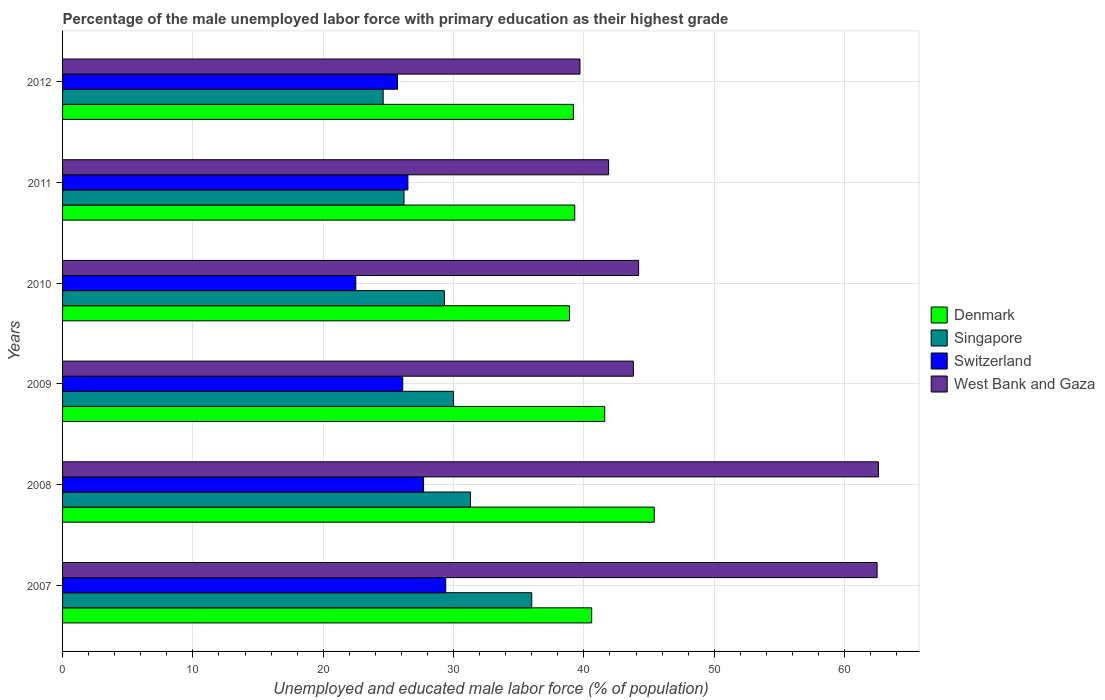How many groups of bars are there?
Your answer should be very brief. 6. How many bars are there on the 2nd tick from the bottom?
Give a very brief answer. 4. What is the label of the 4th group of bars from the top?
Provide a short and direct response. 2009. What is the percentage of the unemployed male labor force with primary education in Switzerland in 2008?
Offer a terse response. 27.7. Across all years, what is the maximum percentage of the unemployed male labor force with primary education in Denmark?
Offer a very short reply. 45.4. In which year was the percentage of the unemployed male labor force with primary education in Singapore minimum?
Give a very brief answer. 2012. What is the total percentage of the unemployed male labor force with primary education in Singapore in the graph?
Your response must be concise. 177.4. What is the difference between the percentage of the unemployed male labor force with primary education in Switzerland in 2008 and that in 2012?
Provide a succinct answer. 2. What is the difference between the percentage of the unemployed male labor force with primary education in Denmark in 2010 and the percentage of the unemployed male labor force with primary education in West Bank and Gaza in 2011?
Your response must be concise. -3. What is the average percentage of the unemployed male labor force with primary education in Switzerland per year?
Your answer should be compact. 26.32. In the year 2012, what is the difference between the percentage of the unemployed male labor force with primary education in West Bank and Gaza and percentage of the unemployed male labor force with primary education in Switzerland?
Your answer should be very brief. 14. What is the ratio of the percentage of the unemployed male labor force with primary education in West Bank and Gaza in 2008 to that in 2009?
Your answer should be compact. 1.43. Is the percentage of the unemployed male labor force with primary education in Denmark in 2008 less than that in 2012?
Keep it short and to the point. No. Is the difference between the percentage of the unemployed male labor force with primary education in West Bank and Gaza in 2007 and 2010 greater than the difference between the percentage of the unemployed male labor force with primary education in Switzerland in 2007 and 2010?
Give a very brief answer. Yes. What is the difference between the highest and the second highest percentage of the unemployed male labor force with primary education in Denmark?
Your answer should be very brief. 3.8. What is the difference between the highest and the lowest percentage of the unemployed male labor force with primary education in Singapore?
Provide a succinct answer. 11.4. Is it the case that in every year, the sum of the percentage of the unemployed male labor force with primary education in Denmark and percentage of the unemployed male labor force with primary education in Singapore is greater than the sum of percentage of the unemployed male labor force with primary education in Switzerland and percentage of the unemployed male labor force with primary education in West Bank and Gaza?
Give a very brief answer. Yes. What does the 3rd bar from the top in 2011 represents?
Your response must be concise. Singapore. Is it the case that in every year, the sum of the percentage of the unemployed male labor force with primary education in Singapore and percentage of the unemployed male labor force with primary education in West Bank and Gaza is greater than the percentage of the unemployed male labor force with primary education in Switzerland?
Keep it short and to the point. Yes. Are all the bars in the graph horizontal?
Provide a succinct answer. Yes. What is the difference between two consecutive major ticks on the X-axis?
Offer a very short reply. 10. Are the values on the major ticks of X-axis written in scientific E-notation?
Make the answer very short. No. Does the graph contain any zero values?
Offer a terse response. No. Does the graph contain grids?
Keep it short and to the point. Yes. How are the legend labels stacked?
Give a very brief answer. Vertical. What is the title of the graph?
Offer a very short reply. Percentage of the male unemployed labor force with primary education as their highest grade. What is the label or title of the X-axis?
Provide a short and direct response. Unemployed and educated male labor force (% of population). What is the Unemployed and educated male labor force (% of population) in Denmark in 2007?
Your response must be concise. 40.6. What is the Unemployed and educated male labor force (% of population) of Singapore in 2007?
Offer a very short reply. 36. What is the Unemployed and educated male labor force (% of population) of Switzerland in 2007?
Your answer should be very brief. 29.4. What is the Unemployed and educated male labor force (% of population) in West Bank and Gaza in 2007?
Offer a very short reply. 62.5. What is the Unemployed and educated male labor force (% of population) in Denmark in 2008?
Provide a short and direct response. 45.4. What is the Unemployed and educated male labor force (% of population) of Singapore in 2008?
Provide a short and direct response. 31.3. What is the Unemployed and educated male labor force (% of population) of Switzerland in 2008?
Your answer should be very brief. 27.7. What is the Unemployed and educated male labor force (% of population) of West Bank and Gaza in 2008?
Your answer should be very brief. 62.6. What is the Unemployed and educated male labor force (% of population) of Denmark in 2009?
Your response must be concise. 41.6. What is the Unemployed and educated male labor force (% of population) in Switzerland in 2009?
Ensure brevity in your answer.  26.1. What is the Unemployed and educated male labor force (% of population) of West Bank and Gaza in 2009?
Your answer should be very brief. 43.8. What is the Unemployed and educated male labor force (% of population) in Denmark in 2010?
Offer a terse response. 38.9. What is the Unemployed and educated male labor force (% of population) in Singapore in 2010?
Make the answer very short. 29.3. What is the Unemployed and educated male labor force (% of population) of Switzerland in 2010?
Give a very brief answer. 22.5. What is the Unemployed and educated male labor force (% of population) of West Bank and Gaza in 2010?
Your answer should be very brief. 44.2. What is the Unemployed and educated male labor force (% of population) of Denmark in 2011?
Offer a terse response. 39.3. What is the Unemployed and educated male labor force (% of population) of Singapore in 2011?
Offer a very short reply. 26.2. What is the Unemployed and educated male labor force (% of population) of West Bank and Gaza in 2011?
Your answer should be very brief. 41.9. What is the Unemployed and educated male labor force (% of population) of Denmark in 2012?
Give a very brief answer. 39.2. What is the Unemployed and educated male labor force (% of population) of Singapore in 2012?
Provide a succinct answer. 24.6. What is the Unemployed and educated male labor force (% of population) in Switzerland in 2012?
Provide a succinct answer. 25.7. What is the Unemployed and educated male labor force (% of population) of West Bank and Gaza in 2012?
Your answer should be compact. 39.7. Across all years, what is the maximum Unemployed and educated male labor force (% of population) of Denmark?
Your answer should be very brief. 45.4. Across all years, what is the maximum Unemployed and educated male labor force (% of population) in Switzerland?
Offer a very short reply. 29.4. Across all years, what is the maximum Unemployed and educated male labor force (% of population) in West Bank and Gaza?
Your answer should be compact. 62.6. Across all years, what is the minimum Unemployed and educated male labor force (% of population) in Denmark?
Ensure brevity in your answer.  38.9. Across all years, what is the minimum Unemployed and educated male labor force (% of population) of Singapore?
Give a very brief answer. 24.6. Across all years, what is the minimum Unemployed and educated male labor force (% of population) in West Bank and Gaza?
Provide a short and direct response. 39.7. What is the total Unemployed and educated male labor force (% of population) of Denmark in the graph?
Keep it short and to the point. 245. What is the total Unemployed and educated male labor force (% of population) of Singapore in the graph?
Your answer should be very brief. 177.4. What is the total Unemployed and educated male labor force (% of population) of Switzerland in the graph?
Ensure brevity in your answer.  157.9. What is the total Unemployed and educated male labor force (% of population) of West Bank and Gaza in the graph?
Provide a succinct answer. 294.7. What is the difference between the Unemployed and educated male labor force (% of population) of Denmark in 2007 and that in 2008?
Provide a succinct answer. -4.8. What is the difference between the Unemployed and educated male labor force (% of population) in Denmark in 2007 and that in 2009?
Ensure brevity in your answer.  -1. What is the difference between the Unemployed and educated male labor force (% of population) of Switzerland in 2007 and that in 2010?
Your answer should be compact. 6.9. What is the difference between the Unemployed and educated male labor force (% of population) in West Bank and Gaza in 2007 and that in 2011?
Your response must be concise. 20.6. What is the difference between the Unemployed and educated male labor force (% of population) of Denmark in 2007 and that in 2012?
Your response must be concise. 1.4. What is the difference between the Unemployed and educated male labor force (% of population) in West Bank and Gaza in 2007 and that in 2012?
Your answer should be compact. 22.8. What is the difference between the Unemployed and educated male labor force (% of population) in Singapore in 2008 and that in 2009?
Give a very brief answer. 1.3. What is the difference between the Unemployed and educated male labor force (% of population) in West Bank and Gaza in 2008 and that in 2009?
Your answer should be compact. 18.8. What is the difference between the Unemployed and educated male labor force (% of population) of Switzerland in 2008 and that in 2010?
Give a very brief answer. 5.2. What is the difference between the Unemployed and educated male labor force (% of population) in Denmark in 2008 and that in 2011?
Your answer should be very brief. 6.1. What is the difference between the Unemployed and educated male labor force (% of population) of Switzerland in 2008 and that in 2011?
Ensure brevity in your answer.  1.2. What is the difference between the Unemployed and educated male labor force (% of population) of West Bank and Gaza in 2008 and that in 2011?
Offer a terse response. 20.7. What is the difference between the Unemployed and educated male labor force (% of population) of Denmark in 2008 and that in 2012?
Provide a short and direct response. 6.2. What is the difference between the Unemployed and educated male labor force (% of population) of Singapore in 2008 and that in 2012?
Provide a succinct answer. 6.7. What is the difference between the Unemployed and educated male labor force (% of population) of West Bank and Gaza in 2008 and that in 2012?
Your answer should be compact. 22.9. What is the difference between the Unemployed and educated male labor force (% of population) in Denmark in 2009 and that in 2010?
Offer a terse response. 2.7. What is the difference between the Unemployed and educated male labor force (% of population) in West Bank and Gaza in 2009 and that in 2010?
Your answer should be very brief. -0.4. What is the difference between the Unemployed and educated male labor force (% of population) of Denmark in 2009 and that in 2011?
Ensure brevity in your answer.  2.3. What is the difference between the Unemployed and educated male labor force (% of population) in Singapore in 2009 and that in 2011?
Your answer should be compact. 3.8. What is the difference between the Unemployed and educated male labor force (% of population) of Switzerland in 2009 and that in 2011?
Make the answer very short. -0.4. What is the difference between the Unemployed and educated male labor force (% of population) of Switzerland in 2009 and that in 2012?
Give a very brief answer. 0.4. What is the difference between the Unemployed and educated male labor force (% of population) of West Bank and Gaza in 2009 and that in 2012?
Provide a succinct answer. 4.1. What is the difference between the Unemployed and educated male labor force (% of population) of Denmark in 2010 and that in 2011?
Provide a succinct answer. -0.4. What is the difference between the Unemployed and educated male labor force (% of population) of Switzerland in 2010 and that in 2011?
Your response must be concise. -4. What is the difference between the Unemployed and educated male labor force (% of population) of West Bank and Gaza in 2010 and that in 2012?
Provide a short and direct response. 4.5. What is the difference between the Unemployed and educated male labor force (% of population) of Denmark in 2011 and that in 2012?
Ensure brevity in your answer.  0.1. What is the difference between the Unemployed and educated male labor force (% of population) in Switzerland in 2011 and that in 2012?
Your answer should be very brief. 0.8. What is the difference between the Unemployed and educated male labor force (% of population) of Denmark in 2007 and the Unemployed and educated male labor force (% of population) of West Bank and Gaza in 2008?
Make the answer very short. -22. What is the difference between the Unemployed and educated male labor force (% of population) of Singapore in 2007 and the Unemployed and educated male labor force (% of population) of Switzerland in 2008?
Your answer should be compact. 8.3. What is the difference between the Unemployed and educated male labor force (% of population) in Singapore in 2007 and the Unemployed and educated male labor force (% of population) in West Bank and Gaza in 2008?
Provide a succinct answer. -26.6. What is the difference between the Unemployed and educated male labor force (% of population) in Switzerland in 2007 and the Unemployed and educated male labor force (% of population) in West Bank and Gaza in 2008?
Offer a very short reply. -33.2. What is the difference between the Unemployed and educated male labor force (% of population) of Singapore in 2007 and the Unemployed and educated male labor force (% of population) of Switzerland in 2009?
Keep it short and to the point. 9.9. What is the difference between the Unemployed and educated male labor force (% of population) of Singapore in 2007 and the Unemployed and educated male labor force (% of population) of West Bank and Gaza in 2009?
Your answer should be very brief. -7.8. What is the difference between the Unemployed and educated male labor force (% of population) of Switzerland in 2007 and the Unemployed and educated male labor force (% of population) of West Bank and Gaza in 2009?
Give a very brief answer. -14.4. What is the difference between the Unemployed and educated male labor force (% of population) in Denmark in 2007 and the Unemployed and educated male labor force (% of population) in Singapore in 2010?
Provide a short and direct response. 11.3. What is the difference between the Unemployed and educated male labor force (% of population) in Denmark in 2007 and the Unemployed and educated male labor force (% of population) in Switzerland in 2010?
Offer a terse response. 18.1. What is the difference between the Unemployed and educated male labor force (% of population) in Denmark in 2007 and the Unemployed and educated male labor force (% of population) in West Bank and Gaza in 2010?
Make the answer very short. -3.6. What is the difference between the Unemployed and educated male labor force (% of population) of Singapore in 2007 and the Unemployed and educated male labor force (% of population) of Switzerland in 2010?
Give a very brief answer. 13.5. What is the difference between the Unemployed and educated male labor force (% of population) of Switzerland in 2007 and the Unemployed and educated male labor force (% of population) of West Bank and Gaza in 2010?
Give a very brief answer. -14.8. What is the difference between the Unemployed and educated male labor force (% of population) in Singapore in 2007 and the Unemployed and educated male labor force (% of population) in West Bank and Gaza in 2011?
Offer a terse response. -5.9. What is the difference between the Unemployed and educated male labor force (% of population) of Denmark in 2007 and the Unemployed and educated male labor force (% of population) of Singapore in 2012?
Keep it short and to the point. 16. What is the difference between the Unemployed and educated male labor force (% of population) in Denmark in 2007 and the Unemployed and educated male labor force (% of population) in Switzerland in 2012?
Make the answer very short. 14.9. What is the difference between the Unemployed and educated male labor force (% of population) of Singapore in 2007 and the Unemployed and educated male labor force (% of population) of Switzerland in 2012?
Give a very brief answer. 10.3. What is the difference between the Unemployed and educated male labor force (% of population) of Singapore in 2007 and the Unemployed and educated male labor force (% of population) of West Bank and Gaza in 2012?
Offer a very short reply. -3.7. What is the difference between the Unemployed and educated male labor force (% of population) in Denmark in 2008 and the Unemployed and educated male labor force (% of population) in Switzerland in 2009?
Offer a very short reply. 19.3. What is the difference between the Unemployed and educated male labor force (% of population) in Singapore in 2008 and the Unemployed and educated male labor force (% of population) in Switzerland in 2009?
Provide a short and direct response. 5.2. What is the difference between the Unemployed and educated male labor force (% of population) of Switzerland in 2008 and the Unemployed and educated male labor force (% of population) of West Bank and Gaza in 2009?
Provide a succinct answer. -16.1. What is the difference between the Unemployed and educated male labor force (% of population) in Denmark in 2008 and the Unemployed and educated male labor force (% of population) in Singapore in 2010?
Provide a succinct answer. 16.1. What is the difference between the Unemployed and educated male labor force (% of population) of Denmark in 2008 and the Unemployed and educated male labor force (% of population) of Switzerland in 2010?
Offer a very short reply. 22.9. What is the difference between the Unemployed and educated male labor force (% of population) of Denmark in 2008 and the Unemployed and educated male labor force (% of population) of West Bank and Gaza in 2010?
Offer a terse response. 1.2. What is the difference between the Unemployed and educated male labor force (% of population) of Singapore in 2008 and the Unemployed and educated male labor force (% of population) of Switzerland in 2010?
Your answer should be compact. 8.8. What is the difference between the Unemployed and educated male labor force (% of population) of Switzerland in 2008 and the Unemployed and educated male labor force (% of population) of West Bank and Gaza in 2010?
Offer a terse response. -16.5. What is the difference between the Unemployed and educated male labor force (% of population) of Denmark in 2008 and the Unemployed and educated male labor force (% of population) of Singapore in 2011?
Give a very brief answer. 19.2. What is the difference between the Unemployed and educated male labor force (% of population) in Denmark in 2008 and the Unemployed and educated male labor force (% of population) in West Bank and Gaza in 2011?
Ensure brevity in your answer.  3.5. What is the difference between the Unemployed and educated male labor force (% of population) in Singapore in 2008 and the Unemployed and educated male labor force (% of population) in West Bank and Gaza in 2011?
Ensure brevity in your answer.  -10.6. What is the difference between the Unemployed and educated male labor force (% of population) in Switzerland in 2008 and the Unemployed and educated male labor force (% of population) in West Bank and Gaza in 2011?
Offer a terse response. -14.2. What is the difference between the Unemployed and educated male labor force (% of population) in Denmark in 2008 and the Unemployed and educated male labor force (% of population) in Singapore in 2012?
Give a very brief answer. 20.8. What is the difference between the Unemployed and educated male labor force (% of population) in Denmark in 2008 and the Unemployed and educated male labor force (% of population) in West Bank and Gaza in 2012?
Your response must be concise. 5.7. What is the difference between the Unemployed and educated male labor force (% of population) in Denmark in 2009 and the Unemployed and educated male labor force (% of population) in Switzerland in 2010?
Ensure brevity in your answer.  19.1. What is the difference between the Unemployed and educated male labor force (% of population) of Singapore in 2009 and the Unemployed and educated male labor force (% of population) of Switzerland in 2010?
Provide a succinct answer. 7.5. What is the difference between the Unemployed and educated male labor force (% of population) of Switzerland in 2009 and the Unemployed and educated male labor force (% of population) of West Bank and Gaza in 2010?
Ensure brevity in your answer.  -18.1. What is the difference between the Unemployed and educated male labor force (% of population) of Switzerland in 2009 and the Unemployed and educated male labor force (% of population) of West Bank and Gaza in 2011?
Your answer should be very brief. -15.8. What is the difference between the Unemployed and educated male labor force (% of population) of Denmark in 2009 and the Unemployed and educated male labor force (% of population) of Singapore in 2012?
Your response must be concise. 17. What is the difference between the Unemployed and educated male labor force (% of population) of Denmark in 2009 and the Unemployed and educated male labor force (% of population) of Switzerland in 2012?
Make the answer very short. 15.9. What is the difference between the Unemployed and educated male labor force (% of population) in Singapore in 2009 and the Unemployed and educated male labor force (% of population) in West Bank and Gaza in 2012?
Your answer should be very brief. -9.7. What is the difference between the Unemployed and educated male labor force (% of population) of Denmark in 2010 and the Unemployed and educated male labor force (% of population) of Switzerland in 2011?
Make the answer very short. 12.4. What is the difference between the Unemployed and educated male labor force (% of population) of Denmark in 2010 and the Unemployed and educated male labor force (% of population) of West Bank and Gaza in 2011?
Offer a very short reply. -3. What is the difference between the Unemployed and educated male labor force (% of population) of Singapore in 2010 and the Unemployed and educated male labor force (% of population) of Switzerland in 2011?
Your response must be concise. 2.8. What is the difference between the Unemployed and educated male labor force (% of population) in Singapore in 2010 and the Unemployed and educated male labor force (% of population) in West Bank and Gaza in 2011?
Provide a succinct answer. -12.6. What is the difference between the Unemployed and educated male labor force (% of population) of Switzerland in 2010 and the Unemployed and educated male labor force (% of population) of West Bank and Gaza in 2011?
Provide a succinct answer. -19.4. What is the difference between the Unemployed and educated male labor force (% of population) of Denmark in 2010 and the Unemployed and educated male labor force (% of population) of Switzerland in 2012?
Keep it short and to the point. 13.2. What is the difference between the Unemployed and educated male labor force (% of population) in Denmark in 2010 and the Unemployed and educated male labor force (% of population) in West Bank and Gaza in 2012?
Ensure brevity in your answer.  -0.8. What is the difference between the Unemployed and educated male labor force (% of population) of Singapore in 2010 and the Unemployed and educated male labor force (% of population) of West Bank and Gaza in 2012?
Make the answer very short. -10.4. What is the difference between the Unemployed and educated male labor force (% of population) in Switzerland in 2010 and the Unemployed and educated male labor force (% of population) in West Bank and Gaza in 2012?
Provide a short and direct response. -17.2. What is the difference between the Unemployed and educated male labor force (% of population) of Singapore in 2011 and the Unemployed and educated male labor force (% of population) of Switzerland in 2012?
Your answer should be compact. 0.5. What is the difference between the Unemployed and educated male labor force (% of population) in Singapore in 2011 and the Unemployed and educated male labor force (% of population) in West Bank and Gaza in 2012?
Keep it short and to the point. -13.5. What is the average Unemployed and educated male labor force (% of population) of Denmark per year?
Ensure brevity in your answer.  40.83. What is the average Unemployed and educated male labor force (% of population) of Singapore per year?
Make the answer very short. 29.57. What is the average Unemployed and educated male labor force (% of population) of Switzerland per year?
Offer a terse response. 26.32. What is the average Unemployed and educated male labor force (% of population) of West Bank and Gaza per year?
Provide a succinct answer. 49.12. In the year 2007, what is the difference between the Unemployed and educated male labor force (% of population) in Denmark and Unemployed and educated male labor force (% of population) in Switzerland?
Your answer should be compact. 11.2. In the year 2007, what is the difference between the Unemployed and educated male labor force (% of population) of Denmark and Unemployed and educated male labor force (% of population) of West Bank and Gaza?
Ensure brevity in your answer.  -21.9. In the year 2007, what is the difference between the Unemployed and educated male labor force (% of population) of Singapore and Unemployed and educated male labor force (% of population) of West Bank and Gaza?
Make the answer very short. -26.5. In the year 2007, what is the difference between the Unemployed and educated male labor force (% of population) of Switzerland and Unemployed and educated male labor force (% of population) of West Bank and Gaza?
Provide a short and direct response. -33.1. In the year 2008, what is the difference between the Unemployed and educated male labor force (% of population) of Denmark and Unemployed and educated male labor force (% of population) of West Bank and Gaza?
Provide a succinct answer. -17.2. In the year 2008, what is the difference between the Unemployed and educated male labor force (% of population) of Singapore and Unemployed and educated male labor force (% of population) of West Bank and Gaza?
Provide a short and direct response. -31.3. In the year 2008, what is the difference between the Unemployed and educated male labor force (% of population) of Switzerland and Unemployed and educated male labor force (% of population) of West Bank and Gaza?
Give a very brief answer. -34.9. In the year 2009, what is the difference between the Unemployed and educated male labor force (% of population) of Singapore and Unemployed and educated male labor force (% of population) of West Bank and Gaza?
Your response must be concise. -13.8. In the year 2009, what is the difference between the Unemployed and educated male labor force (% of population) of Switzerland and Unemployed and educated male labor force (% of population) of West Bank and Gaza?
Make the answer very short. -17.7. In the year 2010, what is the difference between the Unemployed and educated male labor force (% of population) in Denmark and Unemployed and educated male labor force (% of population) in Switzerland?
Your answer should be compact. 16.4. In the year 2010, what is the difference between the Unemployed and educated male labor force (% of population) in Singapore and Unemployed and educated male labor force (% of population) in West Bank and Gaza?
Offer a terse response. -14.9. In the year 2010, what is the difference between the Unemployed and educated male labor force (% of population) in Switzerland and Unemployed and educated male labor force (% of population) in West Bank and Gaza?
Keep it short and to the point. -21.7. In the year 2011, what is the difference between the Unemployed and educated male labor force (% of population) of Denmark and Unemployed and educated male labor force (% of population) of Singapore?
Ensure brevity in your answer.  13.1. In the year 2011, what is the difference between the Unemployed and educated male labor force (% of population) of Denmark and Unemployed and educated male labor force (% of population) of Switzerland?
Offer a terse response. 12.8. In the year 2011, what is the difference between the Unemployed and educated male labor force (% of population) in Singapore and Unemployed and educated male labor force (% of population) in Switzerland?
Make the answer very short. -0.3. In the year 2011, what is the difference between the Unemployed and educated male labor force (% of population) of Singapore and Unemployed and educated male labor force (% of population) of West Bank and Gaza?
Make the answer very short. -15.7. In the year 2011, what is the difference between the Unemployed and educated male labor force (% of population) in Switzerland and Unemployed and educated male labor force (% of population) in West Bank and Gaza?
Offer a very short reply. -15.4. In the year 2012, what is the difference between the Unemployed and educated male labor force (% of population) in Denmark and Unemployed and educated male labor force (% of population) in Singapore?
Make the answer very short. 14.6. In the year 2012, what is the difference between the Unemployed and educated male labor force (% of population) in Denmark and Unemployed and educated male labor force (% of population) in Switzerland?
Offer a terse response. 13.5. In the year 2012, what is the difference between the Unemployed and educated male labor force (% of population) in Singapore and Unemployed and educated male labor force (% of population) in West Bank and Gaza?
Your answer should be compact. -15.1. What is the ratio of the Unemployed and educated male labor force (% of population) of Denmark in 2007 to that in 2008?
Your response must be concise. 0.89. What is the ratio of the Unemployed and educated male labor force (% of population) of Singapore in 2007 to that in 2008?
Make the answer very short. 1.15. What is the ratio of the Unemployed and educated male labor force (% of population) of Switzerland in 2007 to that in 2008?
Your response must be concise. 1.06. What is the ratio of the Unemployed and educated male labor force (% of population) in West Bank and Gaza in 2007 to that in 2008?
Offer a terse response. 1. What is the ratio of the Unemployed and educated male labor force (% of population) of Denmark in 2007 to that in 2009?
Your answer should be very brief. 0.98. What is the ratio of the Unemployed and educated male labor force (% of population) in Switzerland in 2007 to that in 2009?
Provide a short and direct response. 1.13. What is the ratio of the Unemployed and educated male labor force (% of population) of West Bank and Gaza in 2007 to that in 2009?
Your response must be concise. 1.43. What is the ratio of the Unemployed and educated male labor force (% of population) of Denmark in 2007 to that in 2010?
Offer a terse response. 1.04. What is the ratio of the Unemployed and educated male labor force (% of population) of Singapore in 2007 to that in 2010?
Provide a succinct answer. 1.23. What is the ratio of the Unemployed and educated male labor force (% of population) in Switzerland in 2007 to that in 2010?
Keep it short and to the point. 1.31. What is the ratio of the Unemployed and educated male labor force (% of population) of West Bank and Gaza in 2007 to that in 2010?
Make the answer very short. 1.41. What is the ratio of the Unemployed and educated male labor force (% of population) in Denmark in 2007 to that in 2011?
Ensure brevity in your answer.  1.03. What is the ratio of the Unemployed and educated male labor force (% of population) of Singapore in 2007 to that in 2011?
Give a very brief answer. 1.37. What is the ratio of the Unemployed and educated male labor force (% of population) of Switzerland in 2007 to that in 2011?
Provide a succinct answer. 1.11. What is the ratio of the Unemployed and educated male labor force (% of population) of West Bank and Gaza in 2007 to that in 2011?
Give a very brief answer. 1.49. What is the ratio of the Unemployed and educated male labor force (% of population) in Denmark in 2007 to that in 2012?
Provide a short and direct response. 1.04. What is the ratio of the Unemployed and educated male labor force (% of population) in Singapore in 2007 to that in 2012?
Your answer should be compact. 1.46. What is the ratio of the Unemployed and educated male labor force (% of population) in Switzerland in 2007 to that in 2012?
Provide a short and direct response. 1.14. What is the ratio of the Unemployed and educated male labor force (% of population) of West Bank and Gaza in 2007 to that in 2012?
Keep it short and to the point. 1.57. What is the ratio of the Unemployed and educated male labor force (% of population) of Denmark in 2008 to that in 2009?
Your answer should be compact. 1.09. What is the ratio of the Unemployed and educated male labor force (% of population) of Singapore in 2008 to that in 2009?
Provide a short and direct response. 1.04. What is the ratio of the Unemployed and educated male labor force (% of population) of Switzerland in 2008 to that in 2009?
Your answer should be compact. 1.06. What is the ratio of the Unemployed and educated male labor force (% of population) in West Bank and Gaza in 2008 to that in 2009?
Your response must be concise. 1.43. What is the ratio of the Unemployed and educated male labor force (% of population) of Denmark in 2008 to that in 2010?
Keep it short and to the point. 1.17. What is the ratio of the Unemployed and educated male labor force (% of population) in Singapore in 2008 to that in 2010?
Give a very brief answer. 1.07. What is the ratio of the Unemployed and educated male labor force (% of population) of Switzerland in 2008 to that in 2010?
Make the answer very short. 1.23. What is the ratio of the Unemployed and educated male labor force (% of population) in West Bank and Gaza in 2008 to that in 2010?
Offer a very short reply. 1.42. What is the ratio of the Unemployed and educated male labor force (% of population) of Denmark in 2008 to that in 2011?
Offer a very short reply. 1.16. What is the ratio of the Unemployed and educated male labor force (% of population) in Singapore in 2008 to that in 2011?
Make the answer very short. 1.19. What is the ratio of the Unemployed and educated male labor force (% of population) of Switzerland in 2008 to that in 2011?
Provide a succinct answer. 1.05. What is the ratio of the Unemployed and educated male labor force (% of population) in West Bank and Gaza in 2008 to that in 2011?
Offer a terse response. 1.49. What is the ratio of the Unemployed and educated male labor force (% of population) in Denmark in 2008 to that in 2012?
Offer a very short reply. 1.16. What is the ratio of the Unemployed and educated male labor force (% of population) of Singapore in 2008 to that in 2012?
Make the answer very short. 1.27. What is the ratio of the Unemployed and educated male labor force (% of population) in Switzerland in 2008 to that in 2012?
Give a very brief answer. 1.08. What is the ratio of the Unemployed and educated male labor force (% of population) of West Bank and Gaza in 2008 to that in 2012?
Offer a terse response. 1.58. What is the ratio of the Unemployed and educated male labor force (% of population) in Denmark in 2009 to that in 2010?
Make the answer very short. 1.07. What is the ratio of the Unemployed and educated male labor force (% of population) of Singapore in 2009 to that in 2010?
Your answer should be very brief. 1.02. What is the ratio of the Unemployed and educated male labor force (% of population) of Switzerland in 2009 to that in 2010?
Your answer should be compact. 1.16. What is the ratio of the Unemployed and educated male labor force (% of population) of Denmark in 2009 to that in 2011?
Your response must be concise. 1.06. What is the ratio of the Unemployed and educated male labor force (% of population) of Singapore in 2009 to that in 2011?
Keep it short and to the point. 1.15. What is the ratio of the Unemployed and educated male labor force (% of population) of Switzerland in 2009 to that in 2011?
Your answer should be compact. 0.98. What is the ratio of the Unemployed and educated male labor force (% of population) in West Bank and Gaza in 2009 to that in 2011?
Ensure brevity in your answer.  1.05. What is the ratio of the Unemployed and educated male labor force (% of population) in Denmark in 2009 to that in 2012?
Give a very brief answer. 1.06. What is the ratio of the Unemployed and educated male labor force (% of population) in Singapore in 2009 to that in 2012?
Provide a short and direct response. 1.22. What is the ratio of the Unemployed and educated male labor force (% of population) of Switzerland in 2009 to that in 2012?
Provide a short and direct response. 1.02. What is the ratio of the Unemployed and educated male labor force (% of population) of West Bank and Gaza in 2009 to that in 2012?
Ensure brevity in your answer.  1.1. What is the ratio of the Unemployed and educated male labor force (% of population) in Singapore in 2010 to that in 2011?
Your answer should be very brief. 1.12. What is the ratio of the Unemployed and educated male labor force (% of population) of Switzerland in 2010 to that in 2011?
Provide a short and direct response. 0.85. What is the ratio of the Unemployed and educated male labor force (% of population) in West Bank and Gaza in 2010 to that in 2011?
Your answer should be very brief. 1.05. What is the ratio of the Unemployed and educated male labor force (% of population) in Singapore in 2010 to that in 2012?
Provide a short and direct response. 1.19. What is the ratio of the Unemployed and educated male labor force (% of population) of Switzerland in 2010 to that in 2012?
Your answer should be very brief. 0.88. What is the ratio of the Unemployed and educated male labor force (% of population) of West Bank and Gaza in 2010 to that in 2012?
Ensure brevity in your answer.  1.11. What is the ratio of the Unemployed and educated male labor force (% of population) in Denmark in 2011 to that in 2012?
Provide a succinct answer. 1. What is the ratio of the Unemployed and educated male labor force (% of population) of Singapore in 2011 to that in 2012?
Your answer should be compact. 1.06. What is the ratio of the Unemployed and educated male labor force (% of population) in Switzerland in 2011 to that in 2012?
Your answer should be compact. 1.03. What is the ratio of the Unemployed and educated male labor force (% of population) of West Bank and Gaza in 2011 to that in 2012?
Your answer should be compact. 1.06. What is the difference between the highest and the second highest Unemployed and educated male labor force (% of population) in Singapore?
Offer a terse response. 4.7. What is the difference between the highest and the second highest Unemployed and educated male labor force (% of population) of West Bank and Gaza?
Keep it short and to the point. 0.1. What is the difference between the highest and the lowest Unemployed and educated male labor force (% of population) of Switzerland?
Provide a short and direct response. 6.9. What is the difference between the highest and the lowest Unemployed and educated male labor force (% of population) of West Bank and Gaza?
Keep it short and to the point. 22.9. 